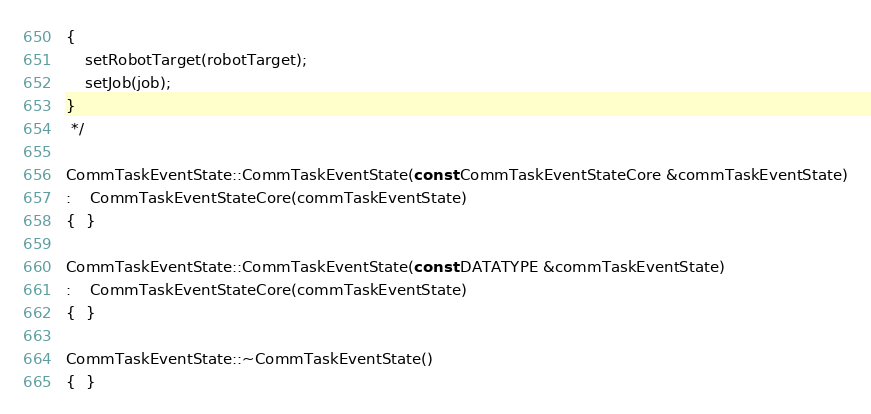Convert code to text. <code><loc_0><loc_0><loc_500><loc_500><_C++_>{
	setRobotTarget(robotTarget);
	setJob(job);
}
 */

CommTaskEventState::CommTaskEventState(const CommTaskEventStateCore &commTaskEventState)
:	CommTaskEventStateCore(commTaskEventState)
{  }

CommTaskEventState::CommTaskEventState(const DATATYPE &commTaskEventState)
:	CommTaskEventStateCore(commTaskEventState)
{  }

CommTaskEventState::~CommTaskEventState()
{  }
</code> 